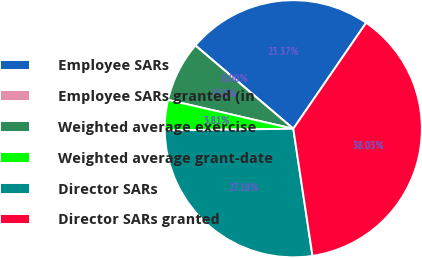<chart> <loc_0><loc_0><loc_500><loc_500><pie_chart><fcel>Employee SARs<fcel>Employee SARs granted (in<fcel>Weighted average exercise<fcel>Weighted average grant-date<fcel>Director SARs<fcel>Director SARs granted<nl><fcel>23.37%<fcel>0.0%<fcel>7.61%<fcel>3.81%<fcel>27.18%<fcel>38.03%<nl></chart> 